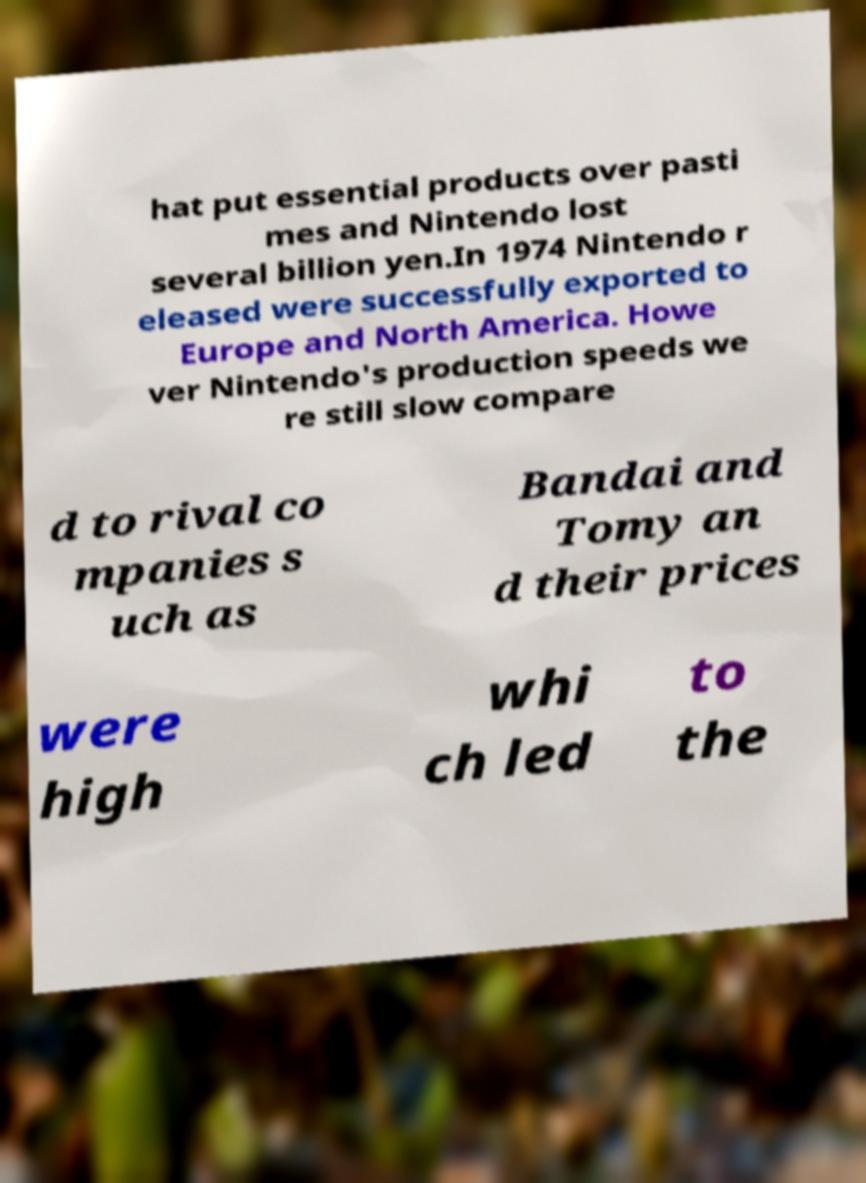Could you assist in decoding the text presented in this image and type it out clearly? hat put essential products over pasti mes and Nintendo lost several billion yen.In 1974 Nintendo r eleased were successfully exported to Europe and North America. Howe ver Nintendo's production speeds we re still slow compare d to rival co mpanies s uch as Bandai and Tomy an d their prices were high whi ch led to the 